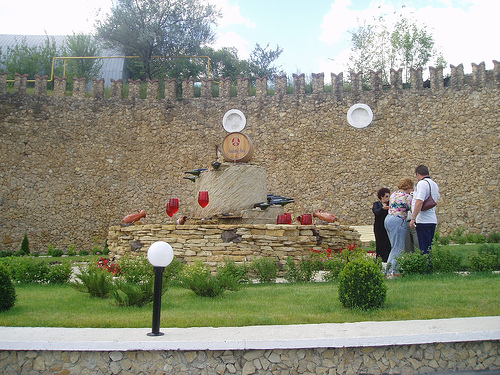<image>
Is the light on the wall? Yes. Looking at the image, I can see the light is positioned on top of the wall, with the wall providing support. 